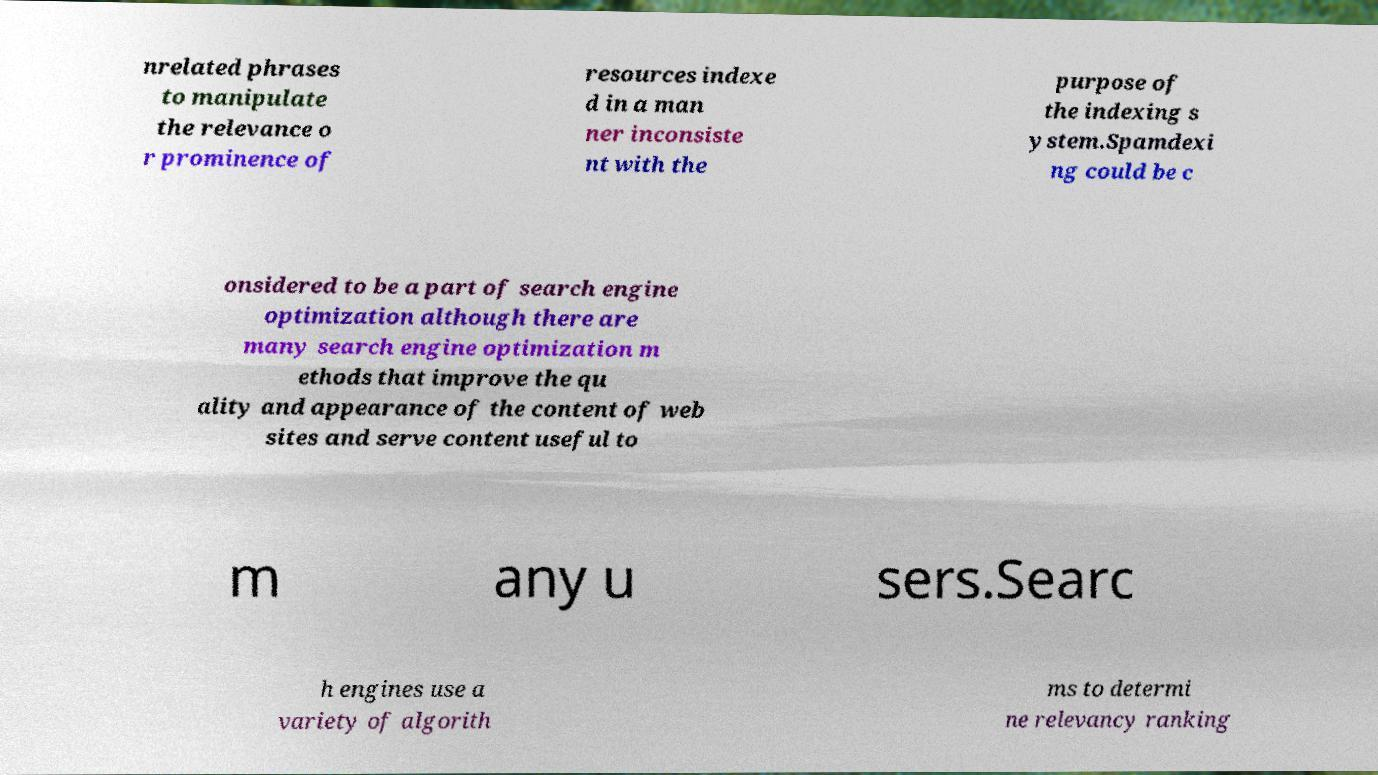Could you assist in decoding the text presented in this image and type it out clearly? nrelated phrases to manipulate the relevance o r prominence of resources indexe d in a man ner inconsiste nt with the purpose of the indexing s ystem.Spamdexi ng could be c onsidered to be a part of search engine optimization although there are many search engine optimization m ethods that improve the qu ality and appearance of the content of web sites and serve content useful to m any u sers.Searc h engines use a variety of algorith ms to determi ne relevancy ranking 